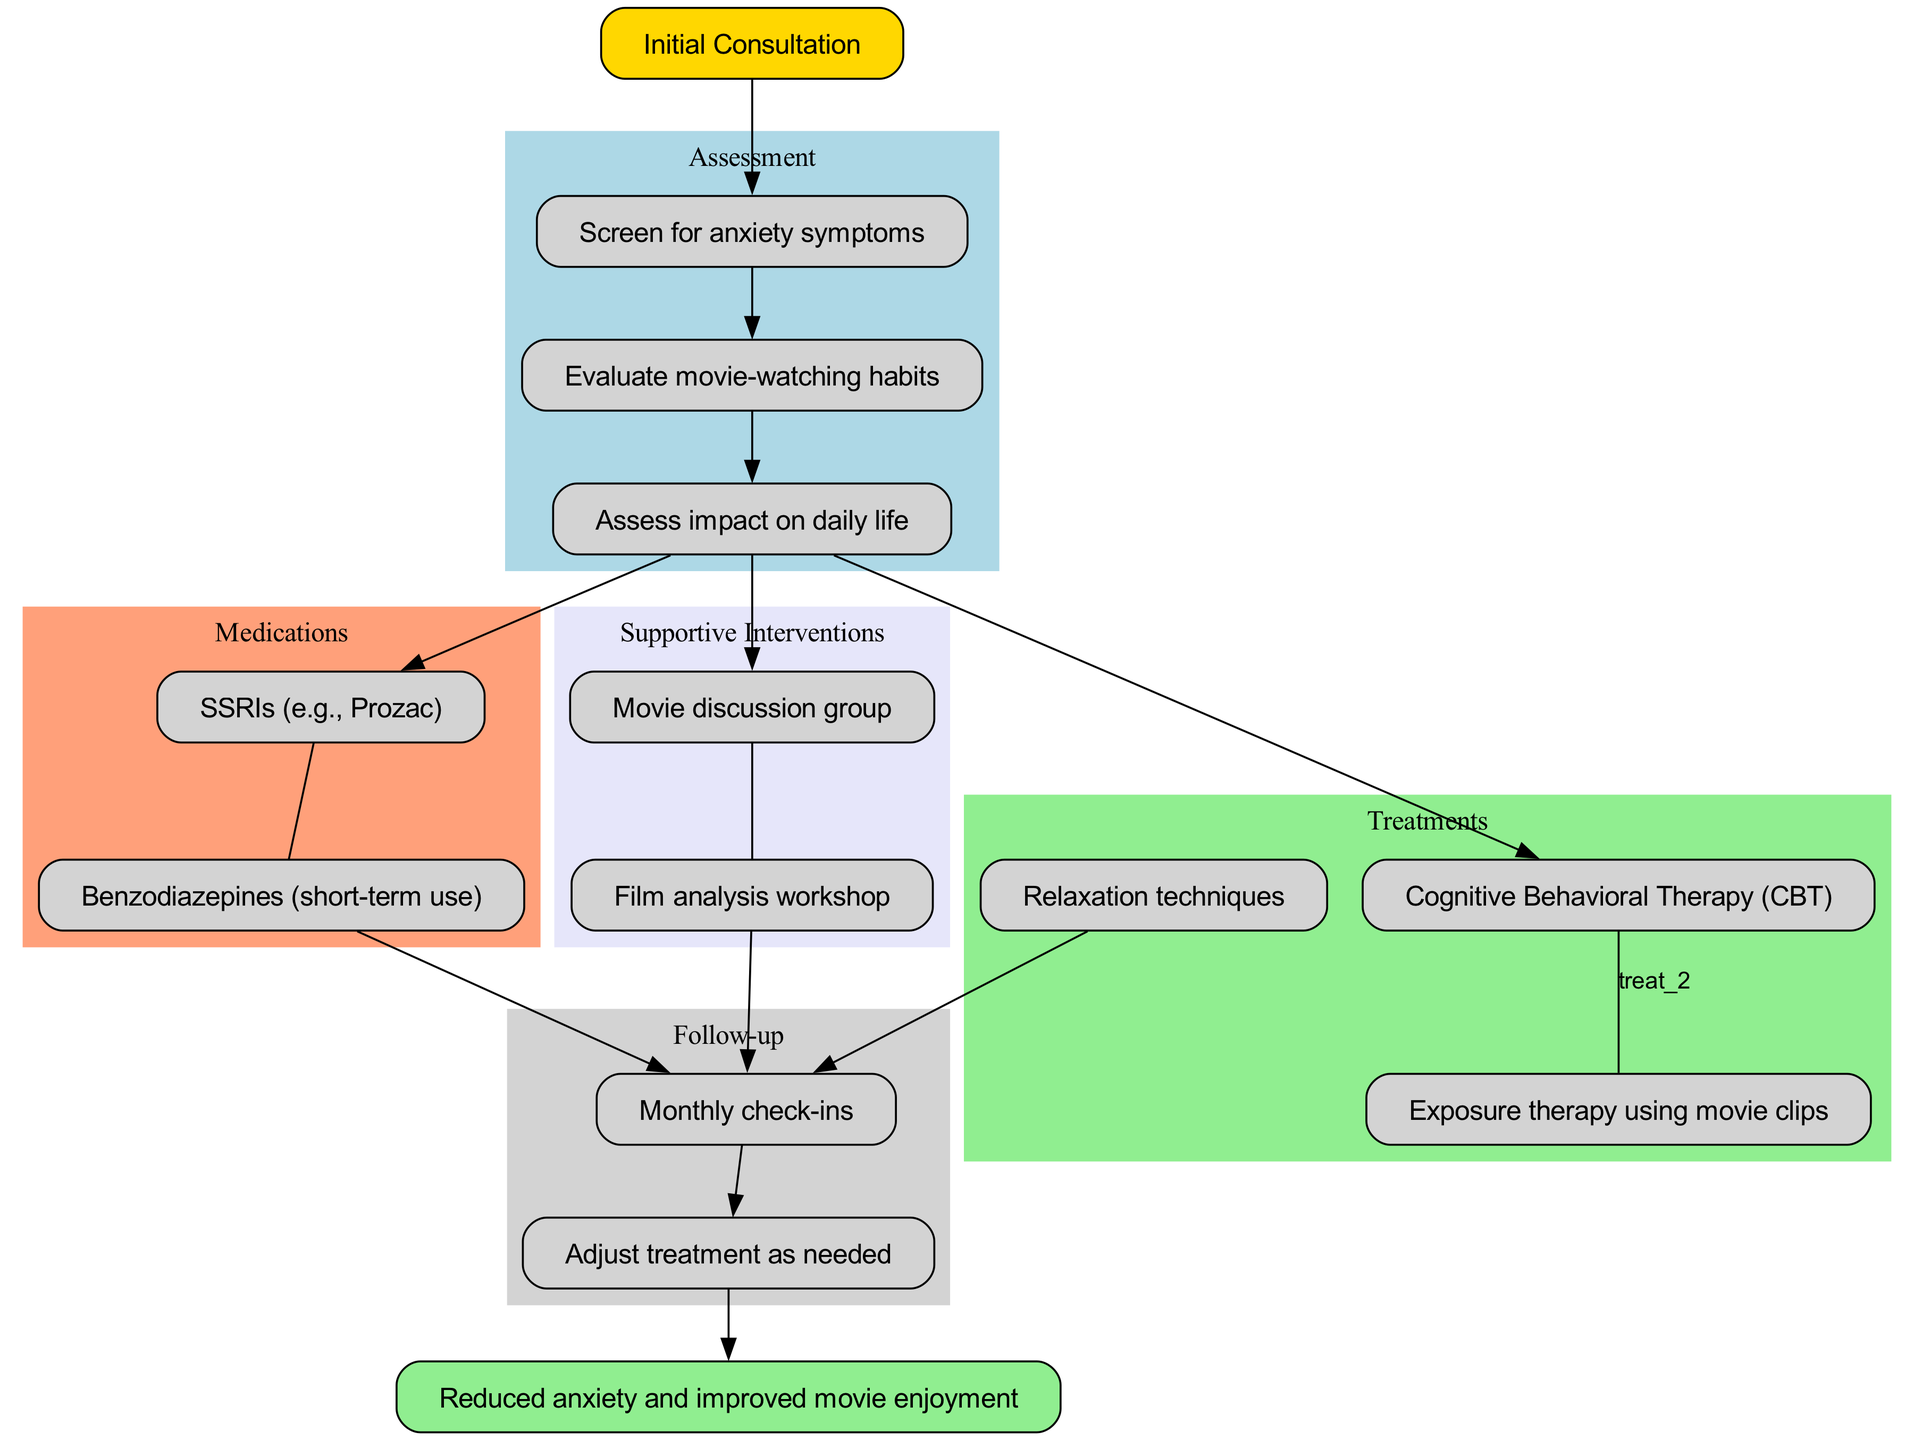What is the starting point of the clinical pathway? The diagram indicates that the starting point is "Initial Consultation," which is the first node connected in the pathway.
Answer: Initial Consultation How many assessment steps are included in the diagram? By counting the listed assessment steps, there are three steps shown from "Screen for anxiety symptoms" to "Assess impact on daily life."
Answer: 3 What type of therapy is highlighted under treatments? The treatments section lists "Cognitive Behavioral Therapy (CBT)" as the first type of therapy provided for addressing anxiety.
Answer: Cognitive Behavioral Therapy (CBT) Which medication is suggested for long-term use? The medications section includes "SSRIs (e.g., Prozac)" which is meant for long-term anxiety management, while benzodiazepines are specified for short-term use.
Answer: SSRIs (e.g., Prozac) What follows after the assessment of its impact on daily life? The arrows connect the assessment step "Assess impact on daily life" to the first treatment option "Cognitive Behavioral Therapy (CBT)," indicating the next stage in the pathway.
Answer: Cognitive Behavioral Therapy (CBT) What is the final endpoint of the clinical pathway? The diagram indicates that the final endpoint is "Reduced anxiety and improved movie enjoyment," clearly stated at the end of the flow.
Answer: Reduced anxiety and improved movie enjoyment How are supportive interventions connected to the treatment and medications? The supportive interventions are connected to the assessment step "Assess impact on daily life," leading to both treatments and medication options to provide a comprehensive approach to anxiety.
Answer: Through the assessment step Which supportive intervention is the first listed? The first supportive intervention mentioned in the diagram is "Movie discussion group," which is the initial node in that cluster.
Answer: Movie discussion group What kind of follow-up is suggested in the pathway? The follow-up suggests "Monthly check-ins," which is the first step in the follow-up section, indicating a regular engagement approach post-treatment.
Answer: Monthly check-ins 